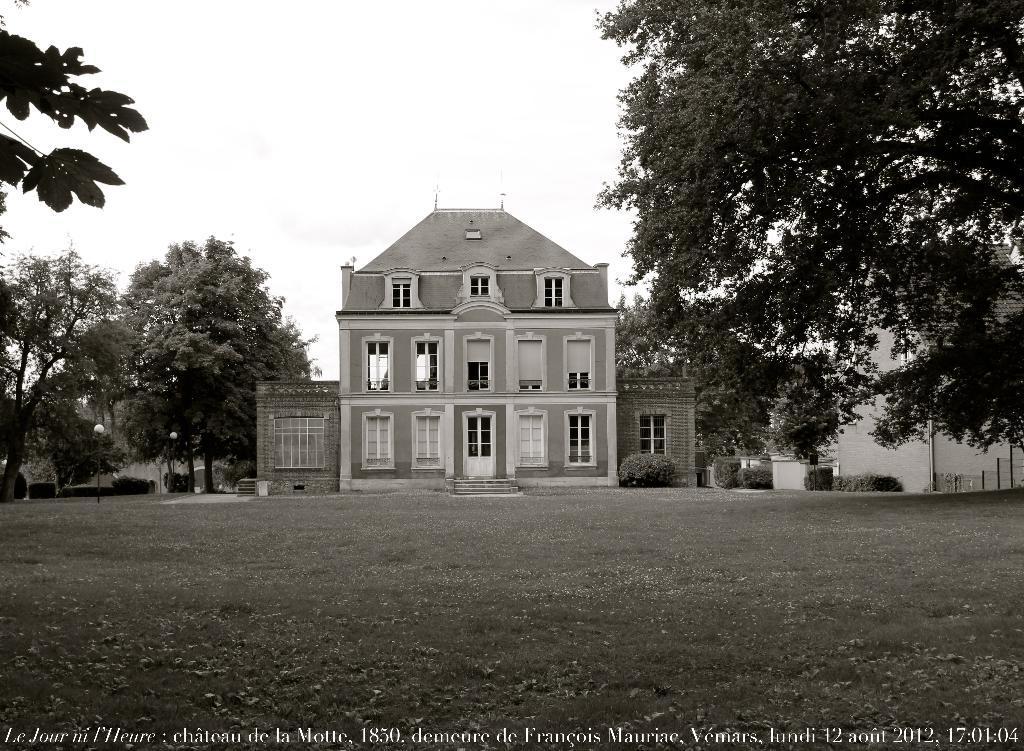Describe this image in one or two sentences. In this image I can see in the middle it is a building, there are trees on either side, at the bottom there is the text in white color. At the top it is the sky. 